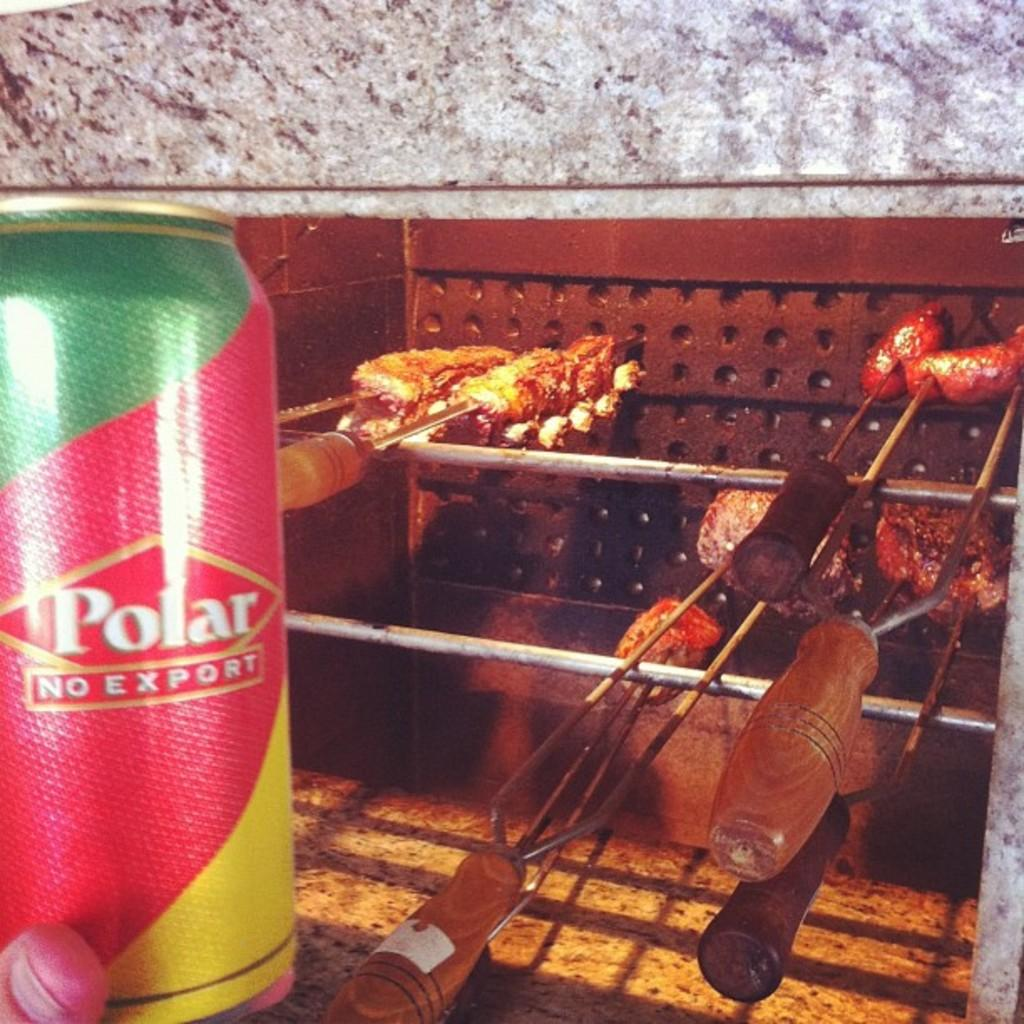What is the main subject in the middle of the image? There is meat in the middle of the image. What can be seen on the left side of the image? There is a tin on the left side of the image. What colors are present on the tin? The tin has green, red, and yellow colors. What is visible in the background of the image? There is a wall in the background of the image. Can you see any trees or a plantation in the image? No, there are no trees or plantation visible in the image. 